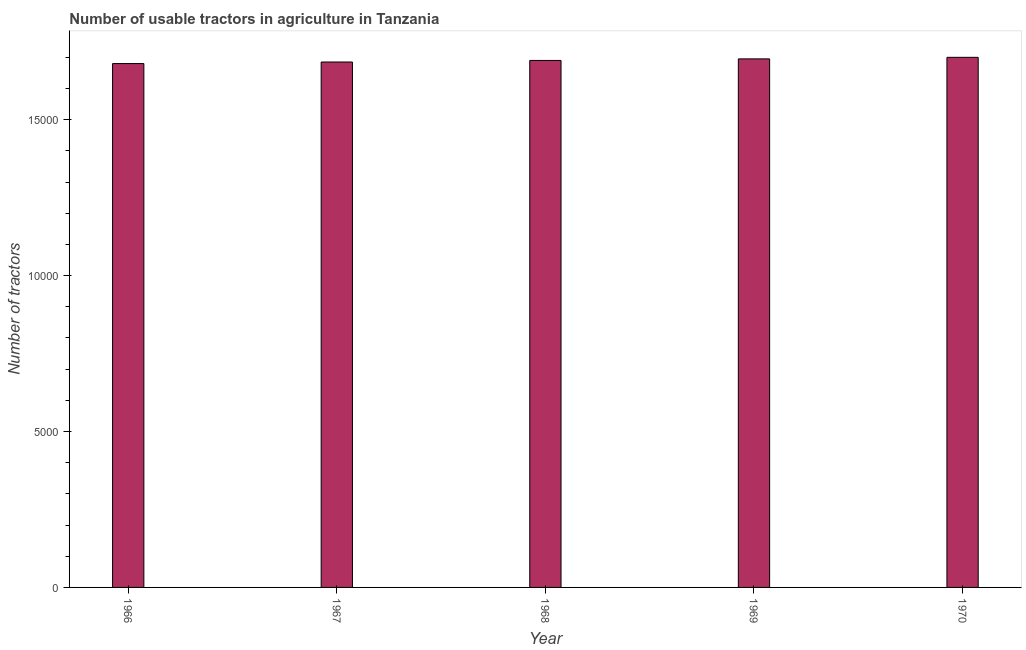Does the graph contain grids?
Offer a terse response. No. What is the title of the graph?
Make the answer very short. Number of usable tractors in agriculture in Tanzania. What is the label or title of the Y-axis?
Offer a very short reply. Number of tractors. What is the number of tractors in 1969?
Provide a succinct answer. 1.70e+04. Across all years, what is the maximum number of tractors?
Your answer should be compact. 1.70e+04. Across all years, what is the minimum number of tractors?
Give a very brief answer. 1.68e+04. In which year was the number of tractors maximum?
Your answer should be compact. 1970. In which year was the number of tractors minimum?
Give a very brief answer. 1966. What is the sum of the number of tractors?
Offer a terse response. 8.45e+04. What is the difference between the number of tractors in 1967 and 1969?
Your answer should be compact. -100. What is the average number of tractors per year?
Give a very brief answer. 1.69e+04. What is the median number of tractors?
Provide a short and direct response. 1.69e+04. In how many years, is the number of tractors greater than 14000 ?
Offer a very short reply. 5. Is the difference between the number of tractors in 1966 and 1967 greater than the difference between any two years?
Ensure brevity in your answer.  No. Is the sum of the number of tractors in 1966 and 1968 greater than the maximum number of tractors across all years?
Offer a terse response. Yes. What is the difference between the highest and the lowest number of tractors?
Provide a succinct answer. 200. In how many years, is the number of tractors greater than the average number of tractors taken over all years?
Keep it short and to the point. 2. How many bars are there?
Keep it short and to the point. 5. How many years are there in the graph?
Make the answer very short. 5. What is the difference between two consecutive major ticks on the Y-axis?
Give a very brief answer. 5000. What is the Number of tractors in 1966?
Provide a succinct answer. 1.68e+04. What is the Number of tractors of 1967?
Keep it short and to the point. 1.68e+04. What is the Number of tractors in 1968?
Your answer should be compact. 1.69e+04. What is the Number of tractors in 1969?
Offer a terse response. 1.70e+04. What is the Number of tractors of 1970?
Ensure brevity in your answer.  1.70e+04. What is the difference between the Number of tractors in 1966 and 1968?
Your answer should be very brief. -100. What is the difference between the Number of tractors in 1966 and 1969?
Your answer should be very brief. -150. What is the difference between the Number of tractors in 1966 and 1970?
Ensure brevity in your answer.  -200. What is the difference between the Number of tractors in 1967 and 1968?
Offer a very short reply. -50. What is the difference between the Number of tractors in 1967 and 1969?
Offer a very short reply. -100. What is the difference between the Number of tractors in 1967 and 1970?
Keep it short and to the point. -150. What is the difference between the Number of tractors in 1968 and 1970?
Keep it short and to the point. -100. What is the ratio of the Number of tractors in 1966 to that in 1968?
Give a very brief answer. 0.99. What is the ratio of the Number of tractors in 1966 to that in 1970?
Provide a succinct answer. 0.99. What is the ratio of the Number of tractors in 1967 to that in 1969?
Your answer should be compact. 0.99. What is the ratio of the Number of tractors in 1967 to that in 1970?
Your response must be concise. 0.99. What is the ratio of the Number of tractors in 1968 to that in 1969?
Provide a succinct answer. 1. What is the ratio of the Number of tractors in 1968 to that in 1970?
Provide a short and direct response. 0.99. 